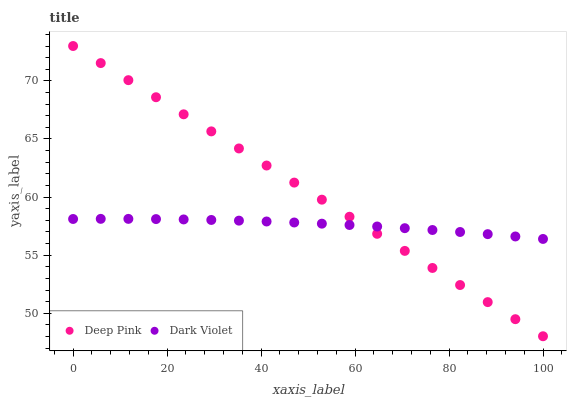Does Dark Violet have the minimum area under the curve?
Answer yes or no. Yes. Does Deep Pink have the maximum area under the curve?
Answer yes or no. Yes. Does Dark Violet have the maximum area under the curve?
Answer yes or no. No. Is Deep Pink the smoothest?
Answer yes or no. Yes. Is Dark Violet the roughest?
Answer yes or no. Yes. Is Dark Violet the smoothest?
Answer yes or no. No. Does Deep Pink have the lowest value?
Answer yes or no. Yes. Does Dark Violet have the lowest value?
Answer yes or no. No. Does Deep Pink have the highest value?
Answer yes or no. Yes. Does Dark Violet have the highest value?
Answer yes or no. No. Does Deep Pink intersect Dark Violet?
Answer yes or no. Yes. Is Deep Pink less than Dark Violet?
Answer yes or no. No. Is Deep Pink greater than Dark Violet?
Answer yes or no. No. 